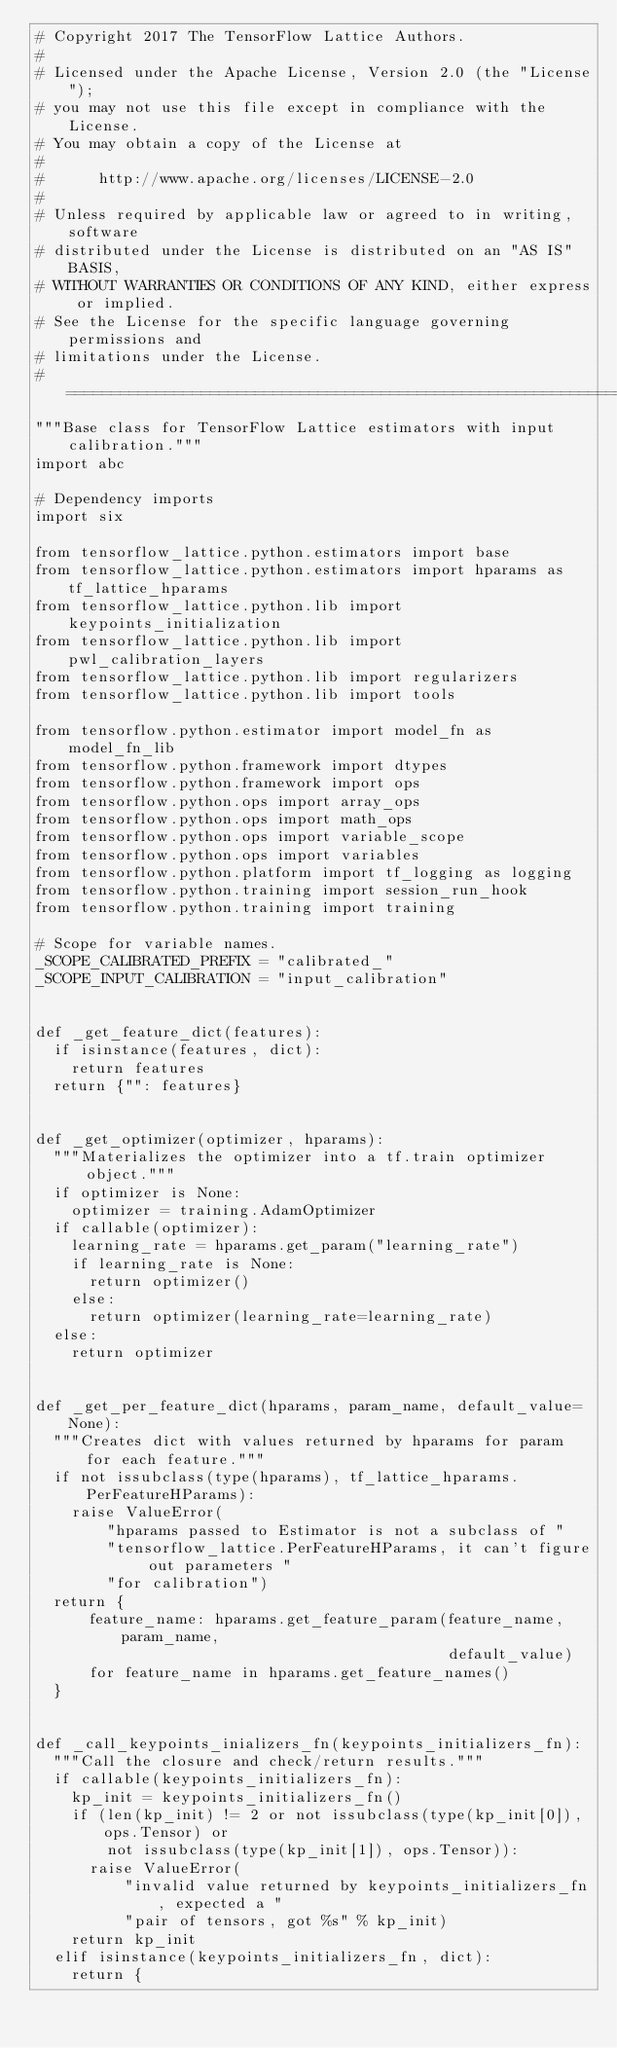<code> <loc_0><loc_0><loc_500><loc_500><_Python_># Copyright 2017 The TensorFlow Lattice Authors.
#
# Licensed under the Apache License, Version 2.0 (the "License");
# you may not use this file except in compliance with the License.
# You may obtain a copy of the License at
#
#      http://www.apache.org/licenses/LICENSE-2.0
#
# Unless required by applicable law or agreed to in writing, software
# distributed under the License is distributed on an "AS IS" BASIS,
# WITHOUT WARRANTIES OR CONDITIONS OF ANY KIND, either express or implied.
# See the License for the specific language governing permissions and
# limitations under the License.
# ==============================================================================
"""Base class for TensorFlow Lattice estimators with input calibration."""
import abc

# Dependency imports
import six

from tensorflow_lattice.python.estimators import base
from tensorflow_lattice.python.estimators import hparams as tf_lattice_hparams
from tensorflow_lattice.python.lib import keypoints_initialization
from tensorflow_lattice.python.lib import pwl_calibration_layers
from tensorflow_lattice.python.lib import regularizers
from tensorflow_lattice.python.lib import tools

from tensorflow.python.estimator import model_fn as model_fn_lib
from tensorflow.python.framework import dtypes
from tensorflow.python.framework import ops
from tensorflow.python.ops import array_ops
from tensorflow.python.ops import math_ops
from tensorflow.python.ops import variable_scope
from tensorflow.python.ops import variables
from tensorflow.python.platform import tf_logging as logging
from tensorflow.python.training import session_run_hook
from tensorflow.python.training import training

# Scope for variable names.
_SCOPE_CALIBRATED_PREFIX = "calibrated_"
_SCOPE_INPUT_CALIBRATION = "input_calibration"


def _get_feature_dict(features):
  if isinstance(features, dict):
    return features
  return {"": features}


def _get_optimizer(optimizer, hparams):
  """Materializes the optimizer into a tf.train optimizer object."""
  if optimizer is None:
    optimizer = training.AdamOptimizer
  if callable(optimizer):
    learning_rate = hparams.get_param("learning_rate")
    if learning_rate is None:
      return optimizer()
    else:
      return optimizer(learning_rate=learning_rate)
  else:
    return optimizer


def _get_per_feature_dict(hparams, param_name, default_value=None):
  """Creates dict with values returned by hparams for param for each feature."""
  if not issubclass(type(hparams), tf_lattice_hparams.PerFeatureHParams):
    raise ValueError(
        "hparams passed to Estimator is not a subclass of "
        "tensorflow_lattice.PerFeatureHParams, it can't figure out parameters "
        "for calibration")
  return {
      feature_name: hparams.get_feature_param(feature_name, param_name,
                                              default_value)
      for feature_name in hparams.get_feature_names()
  }


def _call_keypoints_inializers_fn(keypoints_initializers_fn):
  """Call the closure and check/return results."""
  if callable(keypoints_initializers_fn):
    kp_init = keypoints_initializers_fn()
    if (len(kp_init) != 2 or not issubclass(type(kp_init[0]), ops.Tensor) or
        not issubclass(type(kp_init[1]), ops.Tensor)):
      raise ValueError(
          "invalid value returned by keypoints_initializers_fn, expected a "
          "pair of tensors, got %s" % kp_init)
    return kp_init
  elif isinstance(keypoints_initializers_fn, dict):
    return {</code> 